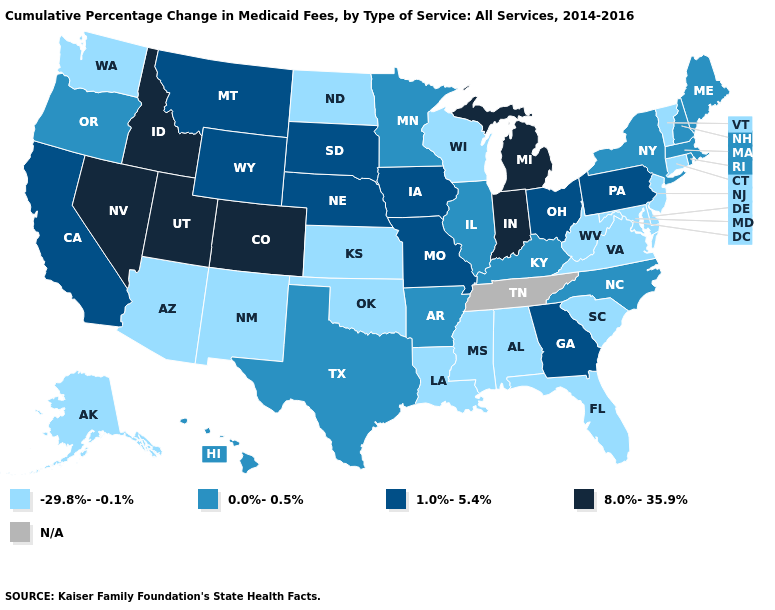How many symbols are there in the legend?
Give a very brief answer. 5. What is the value of Washington?
Concise answer only. -29.8%--0.1%. What is the value of South Dakota?
Answer briefly. 1.0%-5.4%. Among the states that border Michigan , which have the highest value?
Concise answer only. Indiana. Does Nebraska have the highest value in the MidWest?
Short answer required. No. Name the states that have a value in the range N/A?
Quick response, please. Tennessee. Which states have the lowest value in the West?
Write a very short answer. Alaska, Arizona, New Mexico, Washington. Is the legend a continuous bar?
Write a very short answer. No. Name the states that have a value in the range -29.8%--0.1%?
Answer briefly. Alabama, Alaska, Arizona, Connecticut, Delaware, Florida, Kansas, Louisiana, Maryland, Mississippi, New Jersey, New Mexico, North Dakota, Oklahoma, South Carolina, Vermont, Virginia, Washington, West Virginia, Wisconsin. Does the first symbol in the legend represent the smallest category?
Quick response, please. Yes. Does New Hampshire have the lowest value in the Northeast?
Concise answer only. No. What is the value of Missouri?
Give a very brief answer. 1.0%-5.4%. Name the states that have a value in the range 0.0%-0.5%?
Answer briefly. Arkansas, Hawaii, Illinois, Kentucky, Maine, Massachusetts, Minnesota, New Hampshire, New York, North Carolina, Oregon, Rhode Island, Texas. 